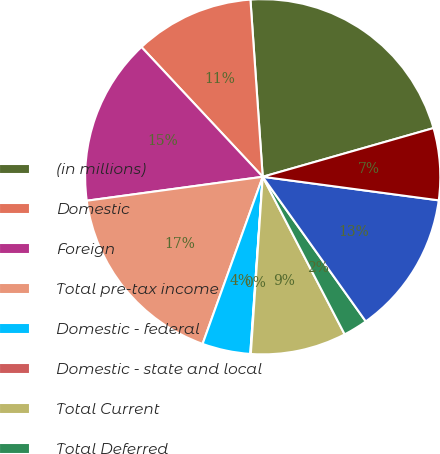Convert chart. <chart><loc_0><loc_0><loc_500><loc_500><pie_chart><fcel>(in millions)<fcel>Domestic<fcel>Foreign<fcel>Total pre-tax income<fcel>Domestic - federal<fcel>Domestic - state and local<fcel>Total Current<fcel>Total Deferred<fcel>Total income tax provision<fcel>Effective income tax rate<nl><fcel>21.68%<fcel>10.86%<fcel>15.19%<fcel>17.35%<fcel>4.38%<fcel>0.05%<fcel>8.7%<fcel>2.22%<fcel>13.03%<fcel>6.54%<nl></chart> 